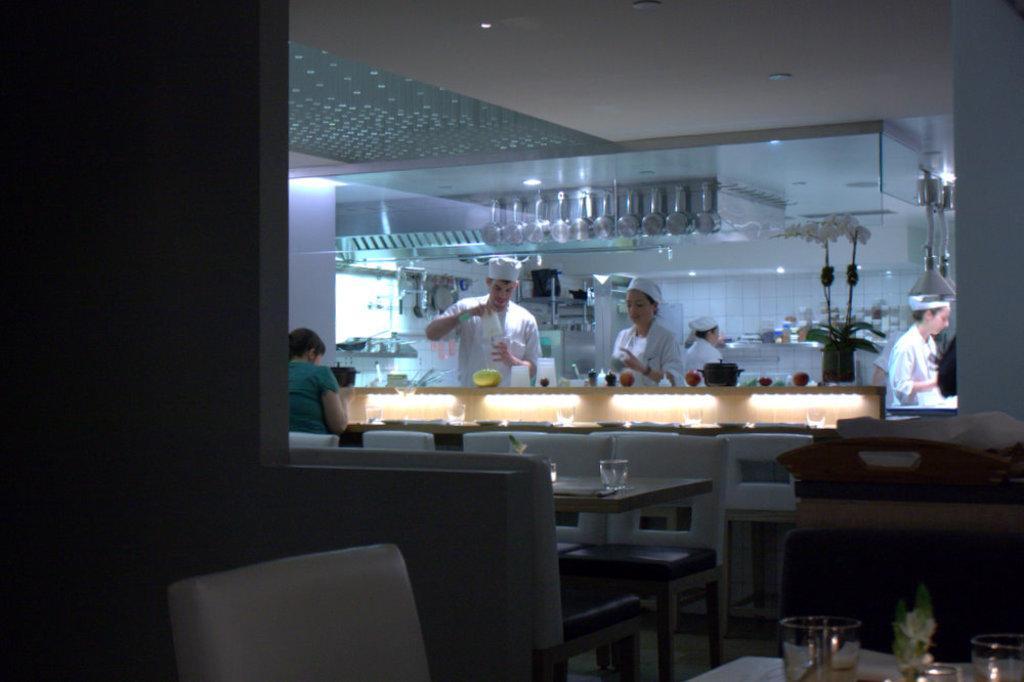Describe this image in one or two sentences. There are tables and chairs. On the tables there are glasses. A person is standing at the left wearing a green shirt. 4 people are standing at the back wearing white caps and white dress. There are utensils and a plant at the back. 